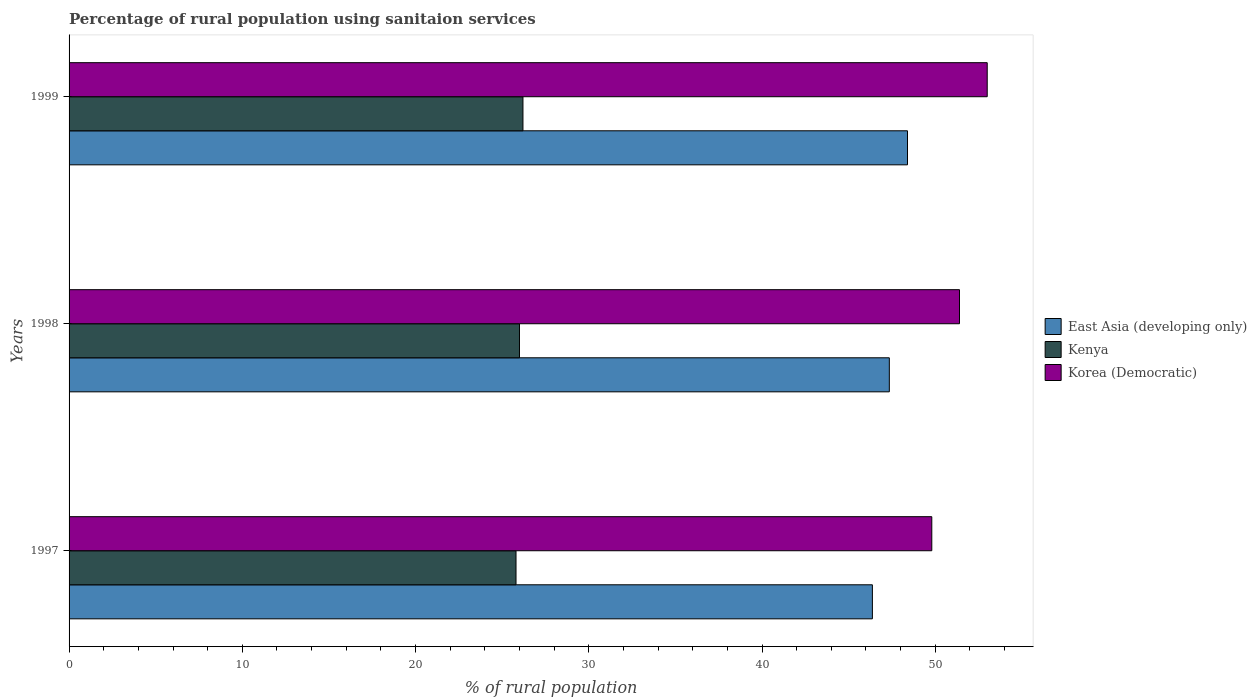How many different coloured bars are there?
Give a very brief answer. 3. How many bars are there on the 3rd tick from the bottom?
Make the answer very short. 3. What is the label of the 1st group of bars from the top?
Your answer should be very brief. 1999. In how many cases, is the number of bars for a given year not equal to the number of legend labels?
Your answer should be very brief. 0. What is the percentage of rural population using sanitaion services in East Asia (developing only) in 1997?
Offer a very short reply. 46.37. Across all years, what is the maximum percentage of rural population using sanitaion services in East Asia (developing only)?
Your answer should be compact. 48.4. Across all years, what is the minimum percentage of rural population using sanitaion services in Kenya?
Your answer should be compact. 25.8. What is the total percentage of rural population using sanitaion services in Korea (Democratic) in the graph?
Your answer should be compact. 154.2. What is the difference between the percentage of rural population using sanitaion services in Kenya in 1997 and that in 1998?
Keep it short and to the point. -0.2. What is the difference between the percentage of rural population using sanitaion services in East Asia (developing only) in 1998 and the percentage of rural population using sanitaion services in Kenya in 1999?
Give a very brief answer. 21.15. What is the average percentage of rural population using sanitaion services in Kenya per year?
Offer a terse response. 26. In the year 1997, what is the difference between the percentage of rural population using sanitaion services in East Asia (developing only) and percentage of rural population using sanitaion services in Korea (Democratic)?
Offer a terse response. -3.43. In how many years, is the percentage of rural population using sanitaion services in Kenya greater than 48 %?
Keep it short and to the point. 0. What is the ratio of the percentage of rural population using sanitaion services in Korea (Democratic) in 1998 to that in 1999?
Keep it short and to the point. 0.97. Is the percentage of rural population using sanitaion services in Kenya in 1997 less than that in 1999?
Offer a terse response. Yes. Is the difference between the percentage of rural population using sanitaion services in East Asia (developing only) in 1997 and 1999 greater than the difference between the percentage of rural population using sanitaion services in Korea (Democratic) in 1997 and 1999?
Offer a terse response. Yes. What is the difference between the highest and the second highest percentage of rural population using sanitaion services in Korea (Democratic)?
Provide a short and direct response. 1.6. What is the difference between the highest and the lowest percentage of rural population using sanitaion services in Kenya?
Your answer should be very brief. 0.4. What does the 3rd bar from the top in 1998 represents?
Your answer should be very brief. East Asia (developing only). What does the 1st bar from the bottom in 1998 represents?
Your answer should be very brief. East Asia (developing only). Is it the case that in every year, the sum of the percentage of rural population using sanitaion services in Korea (Democratic) and percentage of rural population using sanitaion services in Kenya is greater than the percentage of rural population using sanitaion services in East Asia (developing only)?
Your answer should be very brief. Yes. What is the difference between two consecutive major ticks on the X-axis?
Provide a short and direct response. 10. Are the values on the major ticks of X-axis written in scientific E-notation?
Provide a short and direct response. No. Does the graph contain any zero values?
Your response must be concise. No. Does the graph contain grids?
Give a very brief answer. No. How many legend labels are there?
Keep it short and to the point. 3. How are the legend labels stacked?
Offer a very short reply. Vertical. What is the title of the graph?
Your answer should be compact. Percentage of rural population using sanitaion services. What is the label or title of the X-axis?
Your response must be concise. % of rural population. What is the % of rural population of East Asia (developing only) in 1997?
Provide a succinct answer. 46.37. What is the % of rural population of Kenya in 1997?
Offer a very short reply. 25.8. What is the % of rural population in Korea (Democratic) in 1997?
Give a very brief answer. 49.8. What is the % of rural population in East Asia (developing only) in 1998?
Provide a succinct answer. 47.35. What is the % of rural population of Kenya in 1998?
Your answer should be compact. 26. What is the % of rural population in Korea (Democratic) in 1998?
Give a very brief answer. 51.4. What is the % of rural population in East Asia (developing only) in 1999?
Provide a short and direct response. 48.4. What is the % of rural population of Kenya in 1999?
Provide a short and direct response. 26.2. Across all years, what is the maximum % of rural population of East Asia (developing only)?
Make the answer very short. 48.4. Across all years, what is the maximum % of rural population in Kenya?
Ensure brevity in your answer.  26.2. Across all years, what is the maximum % of rural population of Korea (Democratic)?
Ensure brevity in your answer.  53. Across all years, what is the minimum % of rural population in East Asia (developing only)?
Keep it short and to the point. 46.37. Across all years, what is the minimum % of rural population of Kenya?
Offer a terse response. 25.8. Across all years, what is the minimum % of rural population of Korea (Democratic)?
Offer a very short reply. 49.8. What is the total % of rural population in East Asia (developing only) in the graph?
Offer a terse response. 142.12. What is the total % of rural population of Kenya in the graph?
Offer a terse response. 78. What is the total % of rural population of Korea (Democratic) in the graph?
Your answer should be very brief. 154.2. What is the difference between the % of rural population of East Asia (developing only) in 1997 and that in 1998?
Your answer should be very brief. -0.98. What is the difference between the % of rural population in Kenya in 1997 and that in 1998?
Your answer should be compact. -0.2. What is the difference between the % of rural population of East Asia (developing only) in 1997 and that in 1999?
Your answer should be very brief. -2.03. What is the difference between the % of rural population in Korea (Democratic) in 1997 and that in 1999?
Your answer should be compact. -3.2. What is the difference between the % of rural population of East Asia (developing only) in 1998 and that in 1999?
Your answer should be very brief. -1.05. What is the difference between the % of rural population in Kenya in 1998 and that in 1999?
Give a very brief answer. -0.2. What is the difference between the % of rural population in Korea (Democratic) in 1998 and that in 1999?
Your answer should be very brief. -1.6. What is the difference between the % of rural population of East Asia (developing only) in 1997 and the % of rural population of Kenya in 1998?
Provide a succinct answer. 20.37. What is the difference between the % of rural population of East Asia (developing only) in 1997 and the % of rural population of Korea (Democratic) in 1998?
Your answer should be very brief. -5.03. What is the difference between the % of rural population of Kenya in 1997 and the % of rural population of Korea (Democratic) in 1998?
Ensure brevity in your answer.  -25.6. What is the difference between the % of rural population in East Asia (developing only) in 1997 and the % of rural population in Kenya in 1999?
Offer a very short reply. 20.17. What is the difference between the % of rural population of East Asia (developing only) in 1997 and the % of rural population of Korea (Democratic) in 1999?
Make the answer very short. -6.63. What is the difference between the % of rural population in Kenya in 1997 and the % of rural population in Korea (Democratic) in 1999?
Your answer should be very brief. -27.2. What is the difference between the % of rural population of East Asia (developing only) in 1998 and the % of rural population of Kenya in 1999?
Offer a terse response. 21.15. What is the difference between the % of rural population in East Asia (developing only) in 1998 and the % of rural population in Korea (Democratic) in 1999?
Your answer should be compact. -5.65. What is the average % of rural population of East Asia (developing only) per year?
Give a very brief answer. 47.37. What is the average % of rural population of Korea (Democratic) per year?
Your response must be concise. 51.4. In the year 1997, what is the difference between the % of rural population of East Asia (developing only) and % of rural population of Kenya?
Offer a very short reply. 20.57. In the year 1997, what is the difference between the % of rural population in East Asia (developing only) and % of rural population in Korea (Democratic)?
Keep it short and to the point. -3.43. In the year 1998, what is the difference between the % of rural population of East Asia (developing only) and % of rural population of Kenya?
Offer a terse response. 21.35. In the year 1998, what is the difference between the % of rural population in East Asia (developing only) and % of rural population in Korea (Democratic)?
Your response must be concise. -4.05. In the year 1998, what is the difference between the % of rural population in Kenya and % of rural population in Korea (Democratic)?
Offer a very short reply. -25.4. In the year 1999, what is the difference between the % of rural population in East Asia (developing only) and % of rural population in Kenya?
Make the answer very short. 22.2. In the year 1999, what is the difference between the % of rural population in East Asia (developing only) and % of rural population in Korea (Democratic)?
Keep it short and to the point. -4.6. In the year 1999, what is the difference between the % of rural population in Kenya and % of rural population in Korea (Democratic)?
Give a very brief answer. -26.8. What is the ratio of the % of rural population in East Asia (developing only) in 1997 to that in 1998?
Provide a short and direct response. 0.98. What is the ratio of the % of rural population of Kenya in 1997 to that in 1998?
Offer a very short reply. 0.99. What is the ratio of the % of rural population in Korea (Democratic) in 1997 to that in 1998?
Ensure brevity in your answer.  0.97. What is the ratio of the % of rural population in East Asia (developing only) in 1997 to that in 1999?
Your answer should be very brief. 0.96. What is the ratio of the % of rural population of Kenya in 1997 to that in 1999?
Provide a succinct answer. 0.98. What is the ratio of the % of rural population of Korea (Democratic) in 1997 to that in 1999?
Make the answer very short. 0.94. What is the ratio of the % of rural population in East Asia (developing only) in 1998 to that in 1999?
Your answer should be compact. 0.98. What is the ratio of the % of rural population in Korea (Democratic) in 1998 to that in 1999?
Your answer should be compact. 0.97. What is the difference between the highest and the second highest % of rural population of East Asia (developing only)?
Your answer should be very brief. 1.05. What is the difference between the highest and the lowest % of rural population of East Asia (developing only)?
Your answer should be compact. 2.03. What is the difference between the highest and the lowest % of rural population in Kenya?
Your answer should be compact. 0.4. What is the difference between the highest and the lowest % of rural population in Korea (Democratic)?
Offer a very short reply. 3.2. 